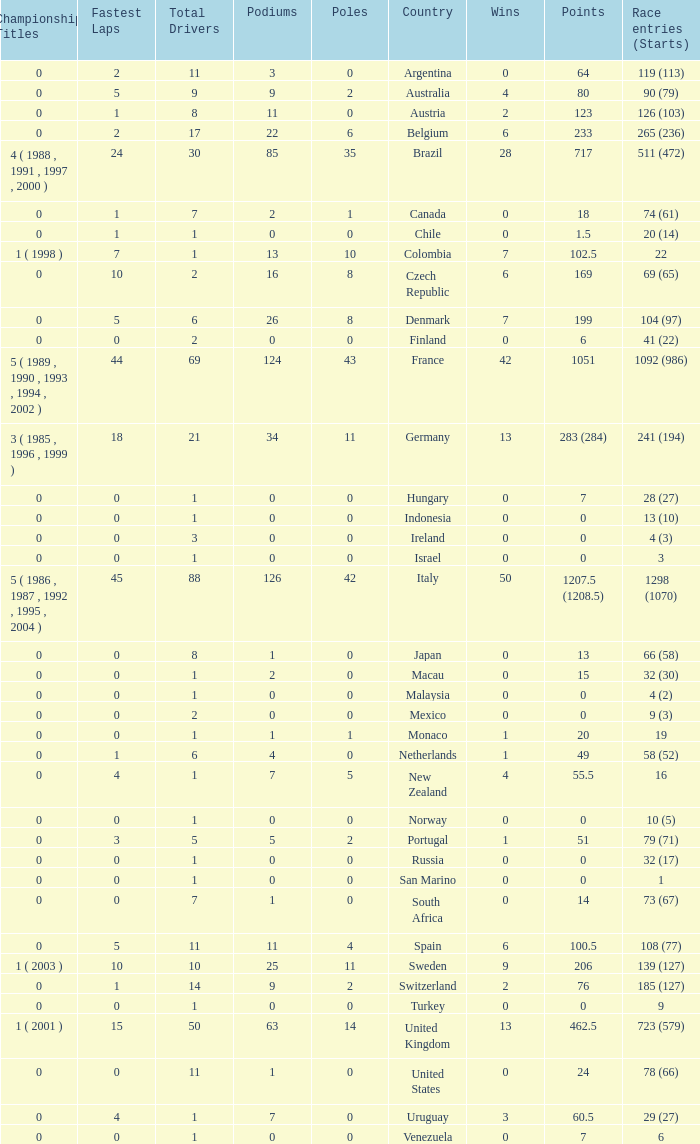How many titles for the nation with less than 3 fastest laps and 22 podiums? 0.0. 